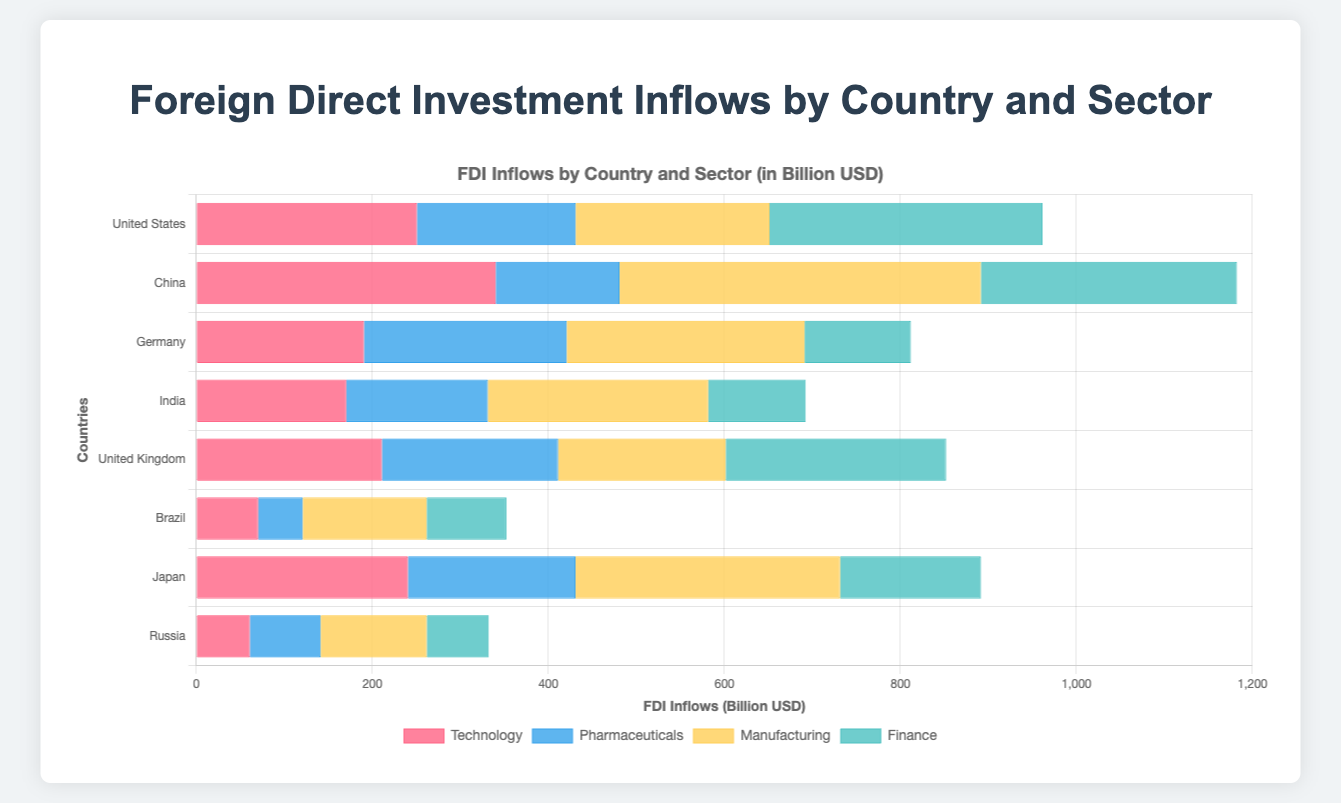Which country has the highest total FDI inflows? To find the country with the highest total FDI inflows, sum the inflows across all sectors for each country. China has the highest total FDI inflows (340.2 + 140.6 + 410.7 + 290.9 = 1,182.4).
Answer: China What is the difference in FDI inflows in the Finance sector between the United States and Germany? The FDI inflows in the Finance sector for the United States is 310.4, and for Germany, it is 120.8. The difference is 310.4 - 120.8.
Answer: 189.6 Which country has the least FDI inflows in the Technology sector? To find the country with the least FDI inflows in the Technology sector, compare the values for Technology among all countries. Russia has the least with 60.8.
Answer: Russia What is the combined FDI inflows for the Pharmaceutical sector in India and Japan? The FDI inflows for the Pharmaceutical sector in India is 160.9, and in Japan, it is 190.3. The combined FDI inflows are 160.9 + 190.3.
Answer: 351.2 Compare the FDI inflows in the Technology sector for China and Brazil. Which country has higher inflows? The FDI inflows in the Technology sector for China is 340.2, and for Brazil, it is 70.2. China has higher inflows.
Answer: China Which sector has the highest overall FDI inflows across all countries? Sum the FDI inflows for each sector across all countries. The Manufacturing sector has the highest overall FDI inflows.
Answer: Manufacturing What is the average FDI inflows for the Finance sector across all countries? To find the average, sum the FDI inflows for the Finance sector across all countries (310.4 + 290.9 + 120.8 + 110.7 + 250.3 + 90.4 + 160.1 + 70.3) and divide by the number of countries (8).
Answer: 175.5 What is the total FDI inflows in the Manufacturing sector for Germany and the United Kingdom? The FDI inflows in the Manufacturing sector for Germany is 270.2, and for the United Kingdom, it is 190.6. The total is 270.2 + 190.6.
Answer: 460.8 Which country has higher FDI inflows in Pharmaceuticals, the United States or the United Kingdom? The FDI inflows in the Pharmaceuticals sector for the United States is 180.3, and for the United Kingdom, it is 200.1. The United Kingdom has higher inflows.
Answer: United Kingdom 